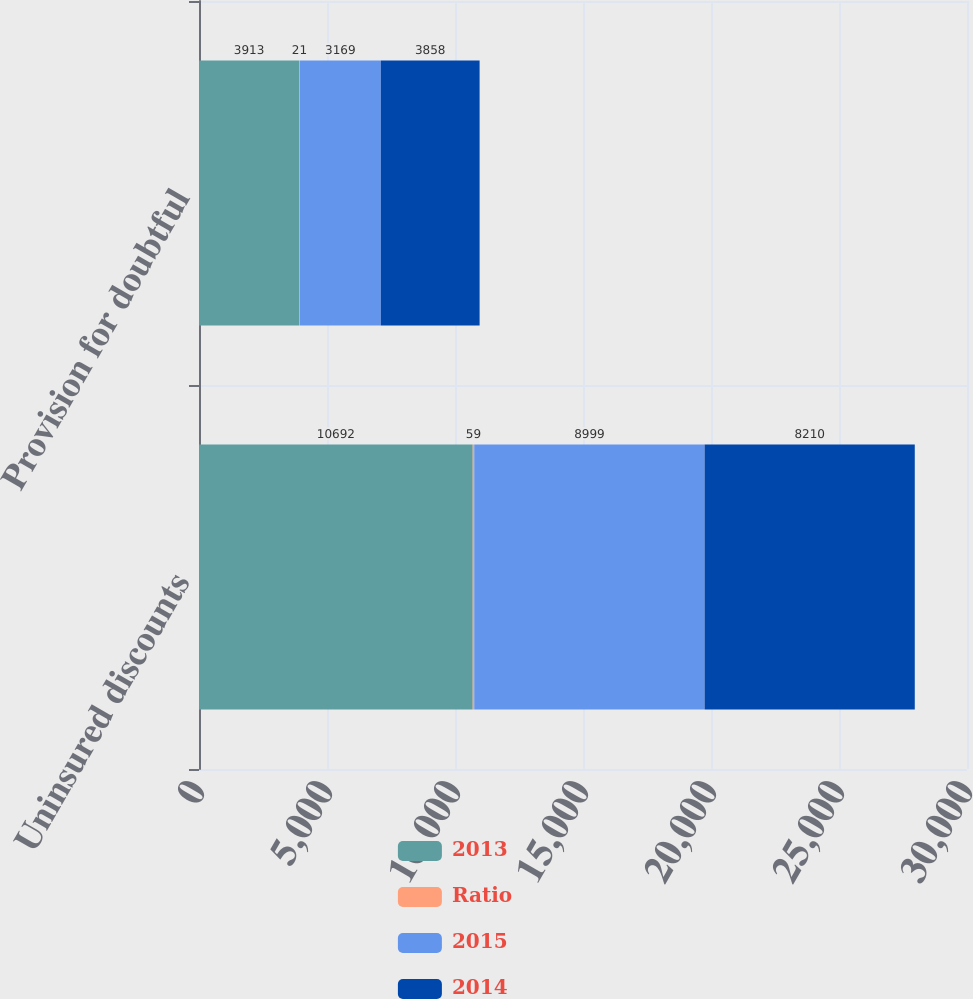Convert chart to OTSL. <chart><loc_0><loc_0><loc_500><loc_500><stacked_bar_chart><ecel><fcel>Uninsured discounts<fcel>Provision for doubtful<nl><fcel>2013<fcel>10692<fcel>3913<nl><fcel>Ratio<fcel>59<fcel>21<nl><fcel>2015<fcel>8999<fcel>3169<nl><fcel>2014<fcel>8210<fcel>3858<nl></chart> 